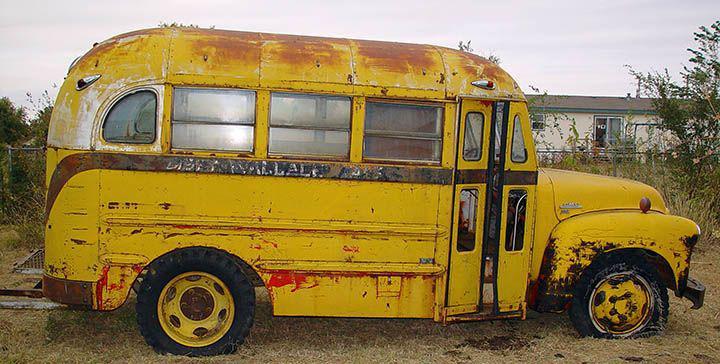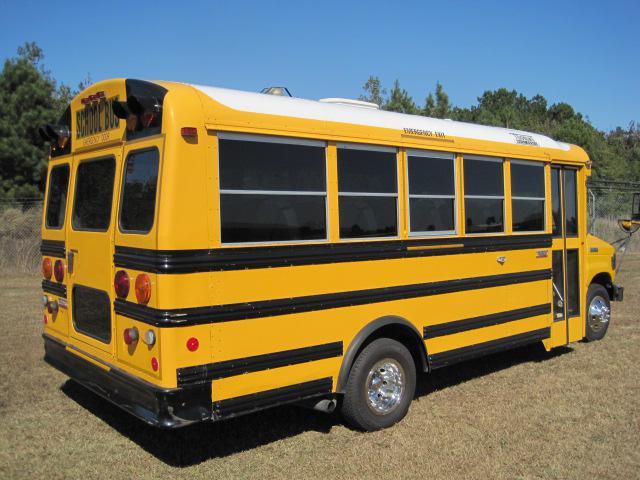The first image is the image on the left, the second image is the image on the right. For the images displayed, is the sentence "Both buses are pointing to the right." factually correct? Answer yes or no. Yes. The first image is the image on the left, the second image is the image on the right. Given the left and right images, does the statement "Left and right images each contain one new-condition yellow bus with a sloped front instead of a flat front and no more than five passenger windows per side." hold true? Answer yes or no. No. 